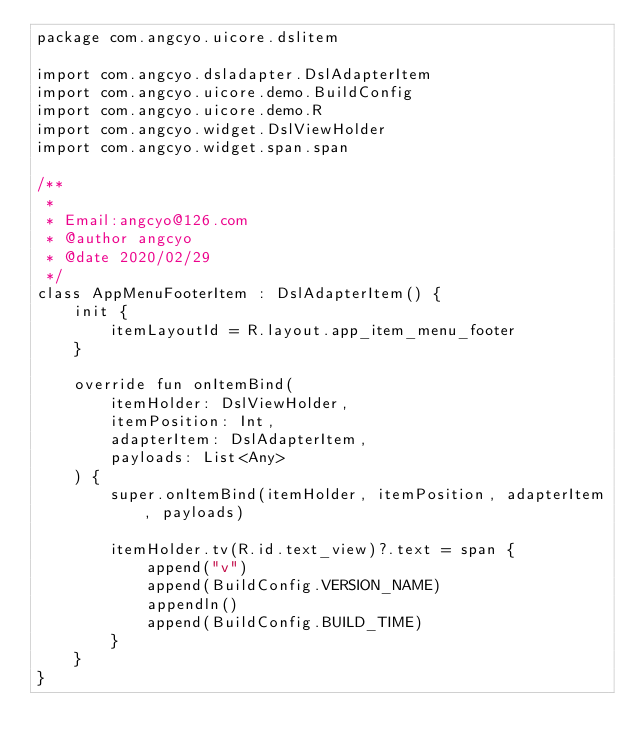<code> <loc_0><loc_0><loc_500><loc_500><_Kotlin_>package com.angcyo.uicore.dslitem

import com.angcyo.dsladapter.DslAdapterItem
import com.angcyo.uicore.demo.BuildConfig
import com.angcyo.uicore.demo.R
import com.angcyo.widget.DslViewHolder
import com.angcyo.widget.span.span

/**
 *
 * Email:angcyo@126.com
 * @author angcyo
 * @date 2020/02/29
 */
class AppMenuFooterItem : DslAdapterItem() {
    init {
        itemLayoutId = R.layout.app_item_menu_footer
    }

    override fun onItemBind(
        itemHolder: DslViewHolder,
        itemPosition: Int,
        adapterItem: DslAdapterItem,
        payloads: List<Any>
    ) {
        super.onItemBind(itemHolder, itemPosition, adapterItem, payloads)

        itemHolder.tv(R.id.text_view)?.text = span {
            append("v")
            append(BuildConfig.VERSION_NAME)
            appendln()
            append(BuildConfig.BUILD_TIME)
        }
    }
}</code> 